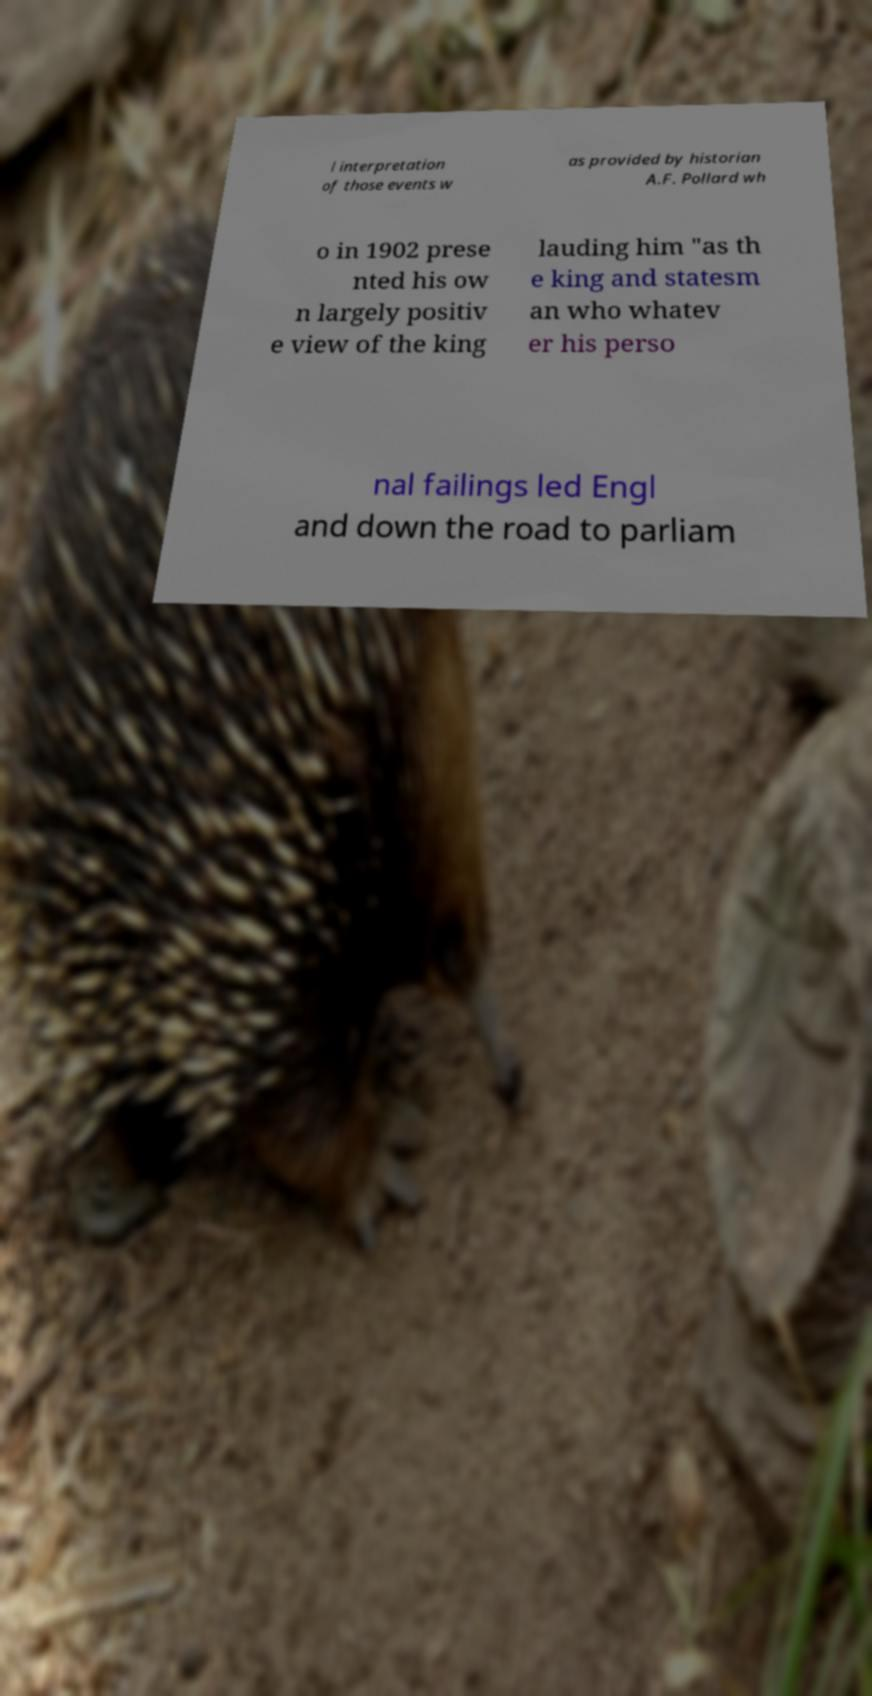Could you assist in decoding the text presented in this image and type it out clearly? l interpretation of those events w as provided by historian A.F. Pollard wh o in 1902 prese nted his ow n largely positiv e view of the king lauding him "as th e king and statesm an who whatev er his perso nal failings led Engl and down the road to parliam 